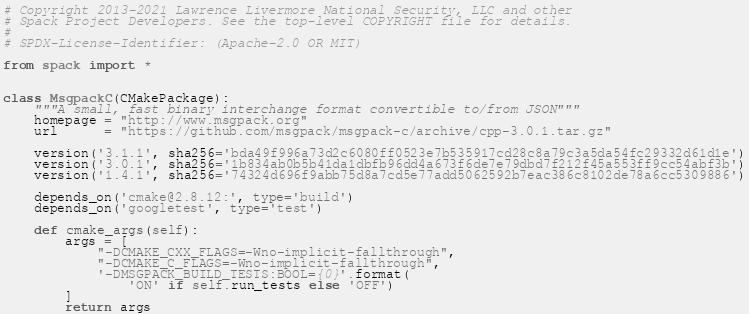<code> <loc_0><loc_0><loc_500><loc_500><_Python_># Copyright 2013-2021 Lawrence Livermore National Security, LLC and other
# Spack Project Developers. See the top-level COPYRIGHT file for details.
#
# SPDX-License-Identifier: (Apache-2.0 OR MIT)

from spack import *


class MsgpackC(CMakePackage):
    """A small, fast binary interchange format convertible to/from JSON"""
    homepage = "http://www.msgpack.org"
    url      = "https://github.com/msgpack/msgpack-c/archive/cpp-3.0.1.tar.gz"

    version('3.1.1', sha256='bda49f996a73d2c6080ff0523e7b535917cd28c8a79c3a5da54fc29332d61d1e')
    version('3.0.1', sha256='1b834ab0b5b41da1dbfb96dd4a673f6de7e79dbd7f212f45a553ff9cc54abf3b')
    version('1.4.1', sha256='74324d696f9abb75d8a7cd5e77add5062592b7eac386c8102de78a6cc5309886')

    depends_on('cmake@2.8.12:', type='build')
    depends_on('googletest', type='test')

    def cmake_args(self):
        args = [
            "-DCMAKE_CXX_FLAGS=-Wno-implicit-fallthrough",
            "-DCMAKE_C_FLAGS=-Wno-implicit-fallthrough",
            '-DMSGPACK_BUILD_TESTS:BOOL={0}'.format(
                'ON' if self.run_tests else 'OFF')
        ]
        return args
</code> 